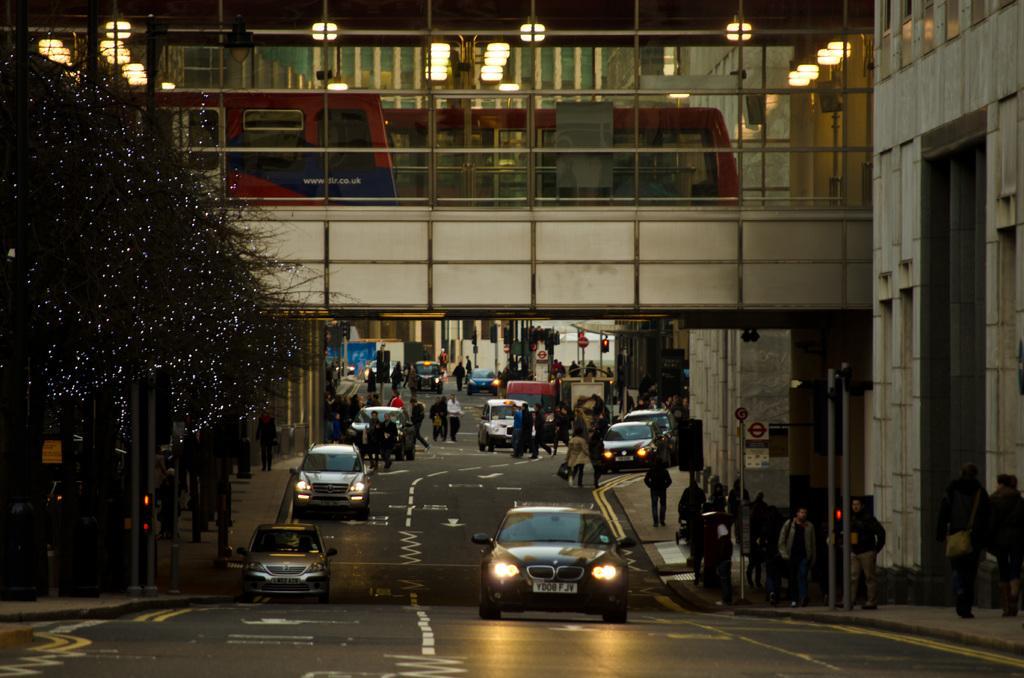Please provide a concise description of this image. On the left there are trees, poles and path. On the right there are buildings, poles and people walking on the footpath. In the center of the picture there are cars, people and road. At the top there are lights and a building. 